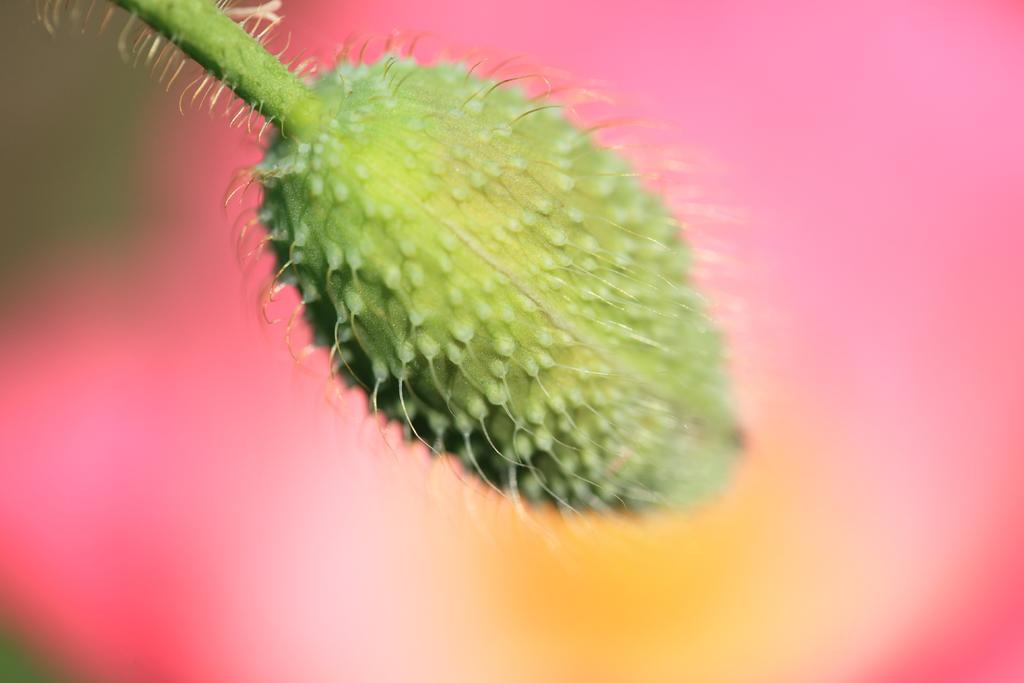What type of food is present in the image? There is a fruit in the image. What is the color of the fruit? The fruit is green in color. Are there any bears eating the green fruit in the image? There is no mention of bears or any animals in the image; it only features a green fruit. 